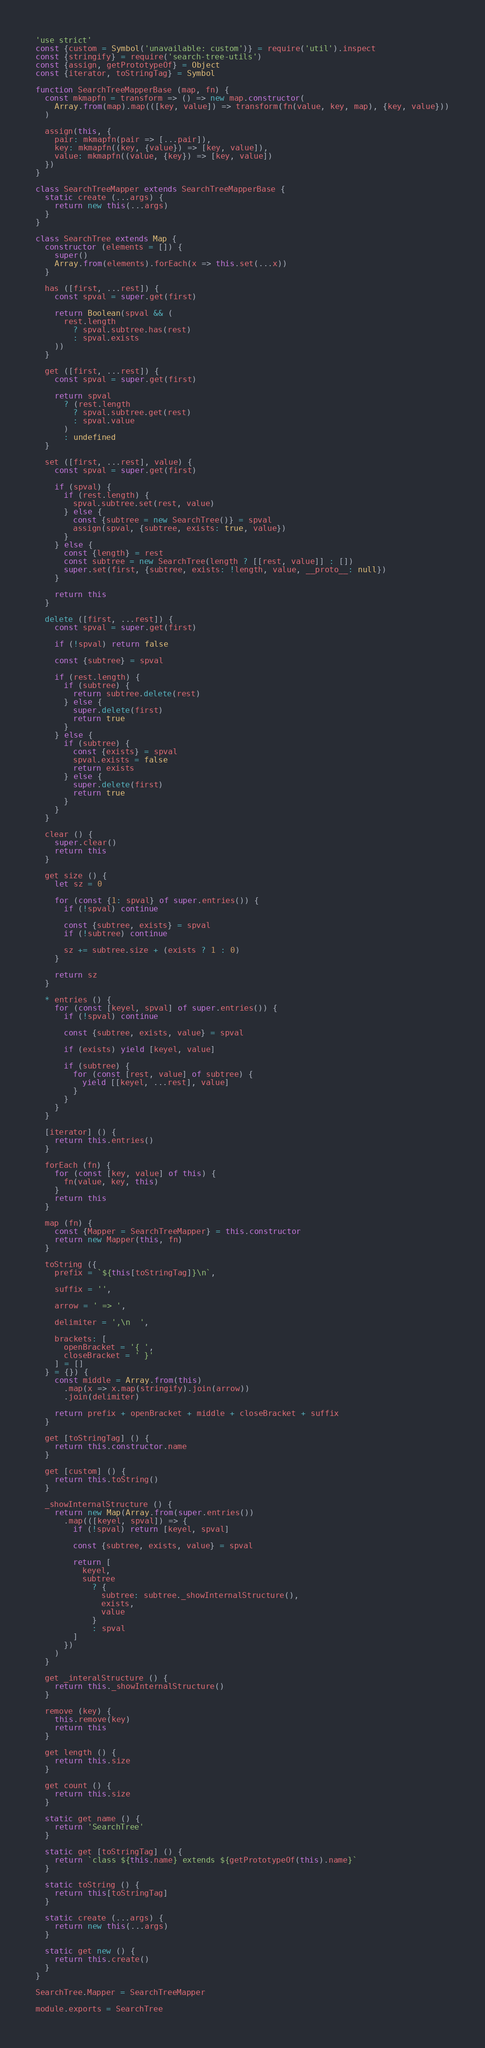<code> <loc_0><loc_0><loc_500><loc_500><_JavaScript_>'use strict'
const {custom = Symbol('unavailable: custom')} = require('util').inspect
const {stringify} = require('search-tree-utils')
const {assign, getPrototypeOf} = Object
const {iterator, toStringTag} = Symbol

function SearchTreeMapperBase (map, fn) {
  const mkmapfn = transform => () => new map.constructor(
    Array.from(map).map(([key, value]) => transform(fn(value, key, map), {key, value}))
  )

  assign(this, {
    pair: mkmapfn(pair => [...pair]),
    key: mkmapfn((key, {value}) => [key, value]),
    value: mkmapfn((value, {key}) => [key, value])
  })
}

class SearchTreeMapper extends SearchTreeMapperBase {
  static create (...args) {
    return new this(...args)
  }
}

class SearchTree extends Map {
  constructor (elements = []) {
    super()
    Array.from(elements).forEach(x => this.set(...x))
  }

  has ([first, ...rest]) {
    const spval = super.get(first)

    return Boolean(spval && (
      rest.length
        ? spval.subtree.has(rest)
        : spval.exists
    ))
  }

  get ([first, ...rest]) {
    const spval = super.get(first)

    return spval
      ? (rest.length
        ? spval.subtree.get(rest)
        : spval.value
      )
      : undefined
  }

  set ([first, ...rest], value) {
    const spval = super.get(first)

    if (spval) {
      if (rest.length) {
        spval.subtree.set(rest, value)
      } else {
        const {subtree = new SearchTree()} = spval
        assign(spval, {subtree, exists: true, value})
      }
    } else {
      const {length} = rest
      const subtree = new SearchTree(length ? [[rest, value]] : [])
      super.set(first, {subtree, exists: !length, value, __proto__: null})
    }

    return this
  }

  delete ([first, ...rest]) {
    const spval = super.get(first)

    if (!spval) return false

    const {subtree} = spval

    if (rest.length) {
      if (subtree) {
        return subtree.delete(rest)
      } else {
        super.delete(first)
        return true
      }
    } else {
      if (subtree) {
        const {exists} = spval
        spval.exists = false
        return exists
      } else {
        super.delete(first)
        return true
      }
    }
  }

  clear () {
    super.clear()
    return this
  }

  get size () {
    let sz = 0

    for (const {1: spval} of super.entries()) {
      if (!spval) continue

      const {subtree, exists} = spval
      if (!subtree) continue

      sz += subtree.size + (exists ? 1 : 0)
    }

    return sz
  }

  * entries () {
    for (const [keyel, spval] of super.entries()) {
      if (!spval) continue

      const {subtree, exists, value} = spval

      if (exists) yield [keyel, value]

      if (subtree) {
        for (const [rest, value] of subtree) {
          yield [[keyel, ...rest], value]
        }
      }
    }
  }

  [iterator] () {
    return this.entries()
  }

  forEach (fn) {
    for (const [key, value] of this) {
      fn(value, key, this)
    }
    return this
  }

  map (fn) {
    const {Mapper = SearchTreeMapper} = this.constructor
    return new Mapper(this, fn)
  }

  toString ({
    prefix = `${this[toStringTag]}\n`,

    suffix = '',

    arrow = ' => ',

    delimiter = ',\n  ',

    brackets: [
      openBracket = '{ ',
      closeBracket = ' }'
    ] = []
  } = {}) {
    const middle = Array.from(this)
      .map(x => x.map(stringify).join(arrow))
      .join(delimiter)

    return prefix + openBracket + middle + closeBracket + suffix
  }

  get [toStringTag] () {
    return this.constructor.name
  }

  get [custom] () {
    return this.toString()
  }

  _showInternalStructure () {
    return new Map(Array.from(super.entries())
      .map(([keyel, spval]) => {
        if (!spval) return [keyel, spval]

        const {subtree, exists, value} = spval

        return [
          keyel,
          subtree
            ? {
              subtree: subtree._showInternalStructure(),
              exists,
              value
            }
            : spval
        ]
      })
    )
  }

  get _interalStructure () {
    return this._showInternalStructure()
  }

  remove (key) {
    this.remove(key)
    return this
  }

  get length () {
    return this.size
  }

  get count () {
    return this.size
  }

  static get name () {
    return 'SearchTree'
  }

  static get [toStringTag] () {
    return `class ${this.name} extends ${getPrototypeOf(this).name}`
  }

  static toString () {
    return this[toStringTag]
  }

  static create (...args) {
    return new this(...args)
  }

  static get new () {
    return this.create()
  }
}

SearchTree.Mapper = SearchTreeMapper

module.exports = SearchTree
</code> 